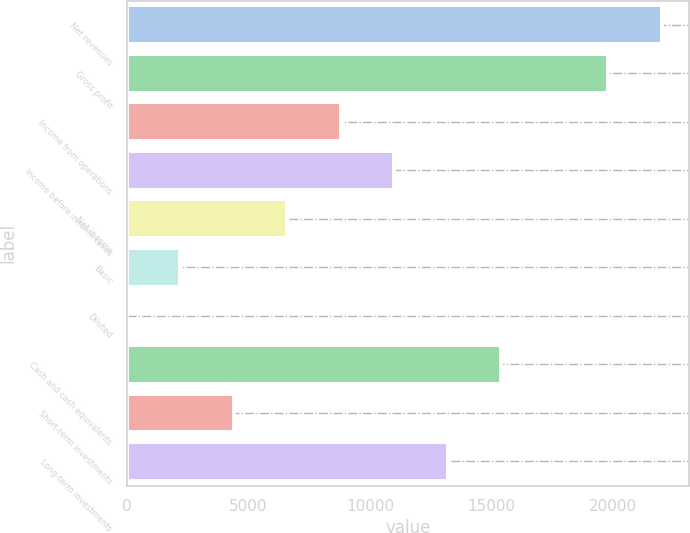Convert chart to OTSL. <chart><loc_0><loc_0><loc_500><loc_500><bar_chart><fcel>Net revenues<fcel>Gross profit<fcel>Income from operations<fcel>Income before income taxes<fcel>Net income<fcel>Basic<fcel>Diluted<fcel>Cash and cash equivalents<fcel>Short-term investments<fcel>Long-term investments<nl><fcel>22004<fcel>19803.7<fcel>8802.4<fcel>11002.7<fcel>6602.14<fcel>2201.62<fcel>1.36<fcel>15403.2<fcel>4401.88<fcel>13202.9<nl></chart> 